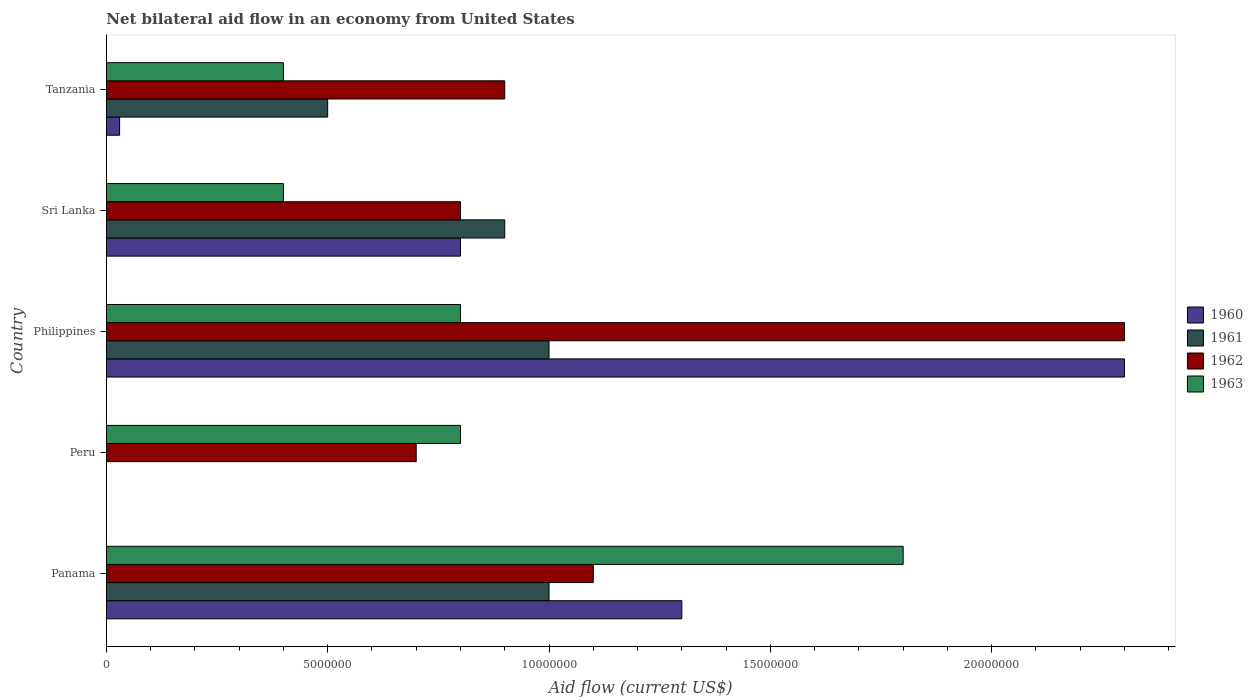How many groups of bars are there?
Your answer should be very brief. 5. Are the number of bars on each tick of the Y-axis equal?
Your response must be concise. No. How many bars are there on the 2nd tick from the bottom?
Your answer should be very brief. 2. What is the label of the 1st group of bars from the top?
Ensure brevity in your answer.  Tanzania. What is the net bilateral aid flow in 1962 in Panama?
Your answer should be compact. 1.10e+07. Across all countries, what is the maximum net bilateral aid flow in 1963?
Give a very brief answer. 1.80e+07. What is the total net bilateral aid flow in 1962 in the graph?
Keep it short and to the point. 5.80e+07. What is the difference between the net bilateral aid flow in 1962 in Peru and that in Tanzania?
Keep it short and to the point. -2.00e+06. What is the difference between the net bilateral aid flow in 1961 in Sri Lanka and the net bilateral aid flow in 1962 in Philippines?
Give a very brief answer. -1.40e+07. What is the average net bilateral aid flow in 1961 per country?
Offer a terse response. 6.80e+06. What is the difference between the net bilateral aid flow in 1963 and net bilateral aid flow in 1962 in Sri Lanka?
Keep it short and to the point. -4.00e+06. What is the ratio of the net bilateral aid flow in 1962 in Panama to that in Sri Lanka?
Give a very brief answer. 1.38. Is the net bilateral aid flow in 1960 in Panama less than that in Philippines?
Give a very brief answer. Yes. What is the difference between the highest and the second highest net bilateral aid flow in 1962?
Offer a very short reply. 1.20e+07. What is the difference between the highest and the lowest net bilateral aid flow in 1963?
Keep it short and to the point. 1.40e+07. Is the sum of the net bilateral aid flow in 1962 in Panama and Tanzania greater than the maximum net bilateral aid flow in 1961 across all countries?
Provide a short and direct response. Yes. Is it the case that in every country, the sum of the net bilateral aid flow in 1963 and net bilateral aid flow in 1961 is greater than the net bilateral aid flow in 1960?
Keep it short and to the point. No. Are all the bars in the graph horizontal?
Keep it short and to the point. Yes. Are the values on the major ticks of X-axis written in scientific E-notation?
Your answer should be very brief. No. How many legend labels are there?
Your answer should be very brief. 4. What is the title of the graph?
Offer a very short reply. Net bilateral aid flow in an economy from United States. Does "1967" appear as one of the legend labels in the graph?
Provide a succinct answer. No. What is the label or title of the X-axis?
Offer a very short reply. Aid flow (current US$). What is the label or title of the Y-axis?
Your response must be concise. Country. What is the Aid flow (current US$) of 1960 in Panama?
Provide a short and direct response. 1.30e+07. What is the Aid flow (current US$) in 1961 in Panama?
Offer a very short reply. 1.00e+07. What is the Aid flow (current US$) in 1962 in Panama?
Ensure brevity in your answer.  1.10e+07. What is the Aid flow (current US$) of 1963 in Panama?
Offer a very short reply. 1.80e+07. What is the Aid flow (current US$) of 1963 in Peru?
Provide a succinct answer. 8.00e+06. What is the Aid flow (current US$) of 1960 in Philippines?
Your answer should be compact. 2.30e+07. What is the Aid flow (current US$) of 1962 in Philippines?
Your answer should be compact. 2.30e+07. What is the Aid flow (current US$) of 1963 in Philippines?
Offer a very short reply. 8.00e+06. What is the Aid flow (current US$) in 1960 in Sri Lanka?
Provide a succinct answer. 8.00e+06. What is the Aid flow (current US$) in 1961 in Sri Lanka?
Your answer should be compact. 9.00e+06. What is the Aid flow (current US$) in 1962 in Sri Lanka?
Your answer should be compact. 8.00e+06. What is the Aid flow (current US$) of 1963 in Sri Lanka?
Keep it short and to the point. 4.00e+06. What is the Aid flow (current US$) in 1960 in Tanzania?
Give a very brief answer. 3.00e+05. What is the Aid flow (current US$) of 1961 in Tanzania?
Give a very brief answer. 5.00e+06. What is the Aid flow (current US$) of 1962 in Tanzania?
Keep it short and to the point. 9.00e+06. Across all countries, what is the maximum Aid flow (current US$) of 1960?
Provide a succinct answer. 2.30e+07. Across all countries, what is the maximum Aid flow (current US$) of 1962?
Your answer should be compact. 2.30e+07. Across all countries, what is the maximum Aid flow (current US$) in 1963?
Make the answer very short. 1.80e+07. Across all countries, what is the minimum Aid flow (current US$) of 1960?
Provide a succinct answer. 0. Across all countries, what is the minimum Aid flow (current US$) in 1961?
Make the answer very short. 0. Across all countries, what is the minimum Aid flow (current US$) of 1963?
Ensure brevity in your answer.  4.00e+06. What is the total Aid flow (current US$) in 1960 in the graph?
Offer a very short reply. 4.43e+07. What is the total Aid flow (current US$) in 1961 in the graph?
Provide a succinct answer. 3.40e+07. What is the total Aid flow (current US$) in 1962 in the graph?
Provide a succinct answer. 5.80e+07. What is the total Aid flow (current US$) in 1963 in the graph?
Make the answer very short. 4.20e+07. What is the difference between the Aid flow (current US$) in 1962 in Panama and that in Peru?
Offer a terse response. 4.00e+06. What is the difference between the Aid flow (current US$) in 1960 in Panama and that in Philippines?
Make the answer very short. -1.00e+07. What is the difference between the Aid flow (current US$) of 1962 in Panama and that in Philippines?
Your answer should be compact. -1.20e+07. What is the difference between the Aid flow (current US$) in 1960 in Panama and that in Sri Lanka?
Your answer should be very brief. 5.00e+06. What is the difference between the Aid flow (current US$) in 1961 in Panama and that in Sri Lanka?
Ensure brevity in your answer.  1.00e+06. What is the difference between the Aid flow (current US$) of 1963 in Panama and that in Sri Lanka?
Your answer should be very brief. 1.40e+07. What is the difference between the Aid flow (current US$) of 1960 in Panama and that in Tanzania?
Offer a very short reply. 1.27e+07. What is the difference between the Aid flow (current US$) in 1962 in Panama and that in Tanzania?
Your answer should be compact. 2.00e+06. What is the difference between the Aid flow (current US$) in 1963 in Panama and that in Tanzania?
Make the answer very short. 1.40e+07. What is the difference between the Aid flow (current US$) of 1962 in Peru and that in Philippines?
Offer a very short reply. -1.60e+07. What is the difference between the Aid flow (current US$) of 1962 in Peru and that in Sri Lanka?
Provide a short and direct response. -1.00e+06. What is the difference between the Aid flow (current US$) in 1962 in Peru and that in Tanzania?
Make the answer very short. -2.00e+06. What is the difference between the Aid flow (current US$) in 1960 in Philippines and that in Sri Lanka?
Provide a short and direct response. 1.50e+07. What is the difference between the Aid flow (current US$) of 1961 in Philippines and that in Sri Lanka?
Keep it short and to the point. 1.00e+06. What is the difference between the Aid flow (current US$) of 1962 in Philippines and that in Sri Lanka?
Give a very brief answer. 1.50e+07. What is the difference between the Aid flow (current US$) of 1963 in Philippines and that in Sri Lanka?
Your answer should be very brief. 4.00e+06. What is the difference between the Aid flow (current US$) of 1960 in Philippines and that in Tanzania?
Make the answer very short. 2.27e+07. What is the difference between the Aid flow (current US$) in 1961 in Philippines and that in Tanzania?
Keep it short and to the point. 5.00e+06. What is the difference between the Aid flow (current US$) of 1962 in Philippines and that in Tanzania?
Provide a succinct answer. 1.40e+07. What is the difference between the Aid flow (current US$) in 1963 in Philippines and that in Tanzania?
Your response must be concise. 4.00e+06. What is the difference between the Aid flow (current US$) in 1960 in Sri Lanka and that in Tanzania?
Your answer should be compact. 7.70e+06. What is the difference between the Aid flow (current US$) in 1961 in Sri Lanka and that in Tanzania?
Your answer should be very brief. 4.00e+06. What is the difference between the Aid flow (current US$) in 1962 in Sri Lanka and that in Tanzania?
Offer a very short reply. -1.00e+06. What is the difference between the Aid flow (current US$) of 1963 in Sri Lanka and that in Tanzania?
Your answer should be compact. 0. What is the difference between the Aid flow (current US$) of 1961 in Panama and the Aid flow (current US$) of 1962 in Peru?
Your response must be concise. 3.00e+06. What is the difference between the Aid flow (current US$) of 1961 in Panama and the Aid flow (current US$) of 1963 in Peru?
Offer a very short reply. 2.00e+06. What is the difference between the Aid flow (current US$) in 1962 in Panama and the Aid flow (current US$) in 1963 in Peru?
Make the answer very short. 3.00e+06. What is the difference between the Aid flow (current US$) of 1960 in Panama and the Aid flow (current US$) of 1962 in Philippines?
Provide a short and direct response. -1.00e+07. What is the difference between the Aid flow (current US$) of 1961 in Panama and the Aid flow (current US$) of 1962 in Philippines?
Your response must be concise. -1.30e+07. What is the difference between the Aid flow (current US$) of 1961 in Panama and the Aid flow (current US$) of 1963 in Philippines?
Make the answer very short. 2.00e+06. What is the difference between the Aid flow (current US$) in 1962 in Panama and the Aid flow (current US$) in 1963 in Philippines?
Offer a very short reply. 3.00e+06. What is the difference between the Aid flow (current US$) in 1960 in Panama and the Aid flow (current US$) in 1961 in Sri Lanka?
Offer a very short reply. 4.00e+06. What is the difference between the Aid flow (current US$) in 1960 in Panama and the Aid flow (current US$) in 1963 in Sri Lanka?
Your response must be concise. 9.00e+06. What is the difference between the Aid flow (current US$) of 1961 in Panama and the Aid flow (current US$) of 1963 in Sri Lanka?
Your answer should be very brief. 6.00e+06. What is the difference between the Aid flow (current US$) in 1962 in Panama and the Aid flow (current US$) in 1963 in Sri Lanka?
Offer a terse response. 7.00e+06. What is the difference between the Aid flow (current US$) in 1960 in Panama and the Aid flow (current US$) in 1961 in Tanzania?
Provide a short and direct response. 8.00e+06. What is the difference between the Aid flow (current US$) of 1960 in Panama and the Aid flow (current US$) of 1963 in Tanzania?
Offer a very short reply. 9.00e+06. What is the difference between the Aid flow (current US$) of 1961 in Panama and the Aid flow (current US$) of 1962 in Tanzania?
Offer a very short reply. 1.00e+06. What is the difference between the Aid flow (current US$) of 1961 in Panama and the Aid flow (current US$) of 1963 in Tanzania?
Make the answer very short. 6.00e+06. What is the difference between the Aid flow (current US$) in 1962 in Panama and the Aid flow (current US$) in 1963 in Tanzania?
Your response must be concise. 7.00e+06. What is the difference between the Aid flow (current US$) of 1962 in Peru and the Aid flow (current US$) of 1963 in Philippines?
Give a very brief answer. -1.00e+06. What is the difference between the Aid flow (current US$) of 1962 in Peru and the Aid flow (current US$) of 1963 in Sri Lanka?
Give a very brief answer. 3.00e+06. What is the difference between the Aid flow (current US$) of 1960 in Philippines and the Aid flow (current US$) of 1961 in Sri Lanka?
Make the answer very short. 1.40e+07. What is the difference between the Aid flow (current US$) in 1960 in Philippines and the Aid flow (current US$) in 1962 in Sri Lanka?
Offer a terse response. 1.50e+07. What is the difference between the Aid flow (current US$) in 1960 in Philippines and the Aid flow (current US$) in 1963 in Sri Lanka?
Keep it short and to the point. 1.90e+07. What is the difference between the Aid flow (current US$) in 1961 in Philippines and the Aid flow (current US$) in 1962 in Sri Lanka?
Your answer should be very brief. 2.00e+06. What is the difference between the Aid flow (current US$) in 1962 in Philippines and the Aid flow (current US$) in 1963 in Sri Lanka?
Provide a succinct answer. 1.90e+07. What is the difference between the Aid flow (current US$) of 1960 in Philippines and the Aid flow (current US$) of 1961 in Tanzania?
Your answer should be compact. 1.80e+07. What is the difference between the Aid flow (current US$) in 1960 in Philippines and the Aid flow (current US$) in 1962 in Tanzania?
Offer a terse response. 1.40e+07. What is the difference between the Aid flow (current US$) in 1960 in Philippines and the Aid flow (current US$) in 1963 in Tanzania?
Your response must be concise. 1.90e+07. What is the difference between the Aid flow (current US$) in 1961 in Philippines and the Aid flow (current US$) in 1962 in Tanzania?
Provide a succinct answer. 1.00e+06. What is the difference between the Aid flow (current US$) of 1961 in Philippines and the Aid flow (current US$) of 1963 in Tanzania?
Offer a terse response. 6.00e+06. What is the difference between the Aid flow (current US$) of 1962 in Philippines and the Aid flow (current US$) of 1963 in Tanzania?
Keep it short and to the point. 1.90e+07. What is the difference between the Aid flow (current US$) of 1960 in Sri Lanka and the Aid flow (current US$) of 1961 in Tanzania?
Your response must be concise. 3.00e+06. What is the average Aid flow (current US$) of 1960 per country?
Provide a short and direct response. 8.86e+06. What is the average Aid flow (current US$) of 1961 per country?
Give a very brief answer. 6.80e+06. What is the average Aid flow (current US$) in 1962 per country?
Your answer should be compact. 1.16e+07. What is the average Aid flow (current US$) in 1963 per country?
Ensure brevity in your answer.  8.40e+06. What is the difference between the Aid flow (current US$) in 1960 and Aid flow (current US$) in 1963 in Panama?
Keep it short and to the point. -5.00e+06. What is the difference between the Aid flow (current US$) of 1961 and Aid flow (current US$) of 1962 in Panama?
Give a very brief answer. -1.00e+06. What is the difference between the Aid flow (current US$) in 1961 and Aid flow (current US$) in 1963 in Panama?
Offer a very short reply. -8.00e+06. What is the difference between the Aid flow (current US$) of 1962 and Aid flow (current US$) of 1963 in Panama?
Your answer should be very brief. -7.00e+06. What is the difference between the Aid flow (current US$) in 1962 and Aid flow (current US$) in 1963 in Peru?
Your answer should be very brief. -1.00e+06. What is the difference between the Aid flow (current US$) in 1960 and Aid flow (current US$) in 1961 in Philippines?
Make the answer very short. 1.30e+07. What is the difference between the Aid flow (current US$) of 1960 and Aid flow (current US$) of 1963 in Philippines?
Your answer should be compact. 1.50e+07. What is the difference between the Aid flow (current US$) of 1961 and Aid flow (current US$) of 1962 in Philippines?
Your answer should be compact. -1.30e+07. What is the difference between the Aid flow (current US$) of 1961 and Aid flow (current US$) of 1963 in Philippines?
Offer a terse response. 2.00e+06. What is the difference between the Aid flow (current US$) in 1962 and Aid flow (current US$) in 1963 in Philippines?
Your response must be concise. 1.50e+07. What is the difference between the Aid flow (current US$) of 1960 and Aid flow (current US$) of 1961 in Sri Lanka?
Your answer should be compact. -1.00e+06. What is the difference between the Aid flow (current US$) of 1960 and Aid flow (current US$) of 1962 in Sri Lanka?
Your response must be concise. 0. What is the difference between the Aid flow (current US$) of 1960 and Aid flow (current US$) of 1963 in Sri Lanka?
Keep it short and to the point. 4.00e+06. What is the difference between the Aid flow (current US$) of 1961 and Aid flow (current US$) of 1963 in Sri Lanka?
Give a very brief answer. 5.00e+06. What is the difference between the Aid flow (current US$) of 1962 and Aid flow (current US$) of 1963 in Sri Lanka?
Provide a short and direct response. 4.00e+06. What is the difference between the Aid flow (current US$) in 1960 and Aid flow (current US$) in 1961 in Tanzania?
Keep it short and to the point. -4.70e+06. What is the difference between the Aid flow (current US$) in 1960 and Aid flow (current US$) in 1962 in Tanzania?
Your answer should be compact. -8.70e+06. What is the difference between the Aid flow (current US$) of 1960 and Aid flow (current US$) of 1963 in Tanzania?
Offer a very short reply. -3.70e+06. What is the difference between the Aid flow (current US$) of 1961 and Aid flow (current US$) of 1962 in Tanzania?
Keep it short and to the point. -4.00e+06. What is the difference between the Aid flow (current US$) in 1961 and Aid flow (current US$) in 1963 in Tanzania?
Offer a terse response. 1.00e+06. What is the ratio of the Aid flow (current US$) in 1962 in Panama to that in Peru?
Your answer should be very brief. 1.57. What is the ratio of the Aid flow (current US$) of 1963 in Panama to that in Peru?
Give a very brief answer. 2.25. What is the ratio of the Aid flow (current US$) in 1960 in Panama to that in Philippines?
Provide a short and direct response. 0.57. What is the ratio of the Aid flow (current US$) of 1961 in Panama to that in Philippines?
Provide a short and direct response. 1. What is the ratio of the Aid flow (current US$) of 1962 in Panama to that in Philippines?
Provide a short and direct response. 0.48. What is the ratio of the Aid flow (current US$) in 1963 in Panama to that in Philippines?
Provide a short and direct response. 2.25. What is the ratio of the Aid flow (current US$) of 1960 in Panama to that in Sri Lanka?
Your answer should be compact. 1.62. What is the ratio of the Aid flow (current US$) in 1961 in Panama to that in Sri Lanka?
Offer a terse response. 1.11. What is the ratio of the Aid flow (current US$) of 1962 in Panama to that in Sri Lanka?
Your response must be concise. 1.38. What is the ratio of the Aid flow (current US$) of 1963 in Panama to that in Sri Lanka?
Provide a short and direct response. 4.5. What is the ratio of the Aid flow (current US$) of 1960 in Panama to that in Tanzania?
Keep it short and to the point. 43.33. What is the ratio of the Aid flow (current US$) of 1961 in Panama to that in Tanzania?
Give a very brief answer. 2. What is the ratio of the Aid flow (current US$) of 1962 in Panama to that in Tanzania?
Give a very brief answer. 1.22. What is the ratio of the Aid flow (current US$) of 1963 in Panama to that in Tanzania?
Your answer should be very brief. 4.5. What is the ratio of the Aid flow (current US$) in 1962 in Peru to that in Philippines?
Your answer should be compact. 0.3. What is the ratio of the Aid flow (current US$) of 1963 in Peru to that in Sri Lanka?
Your answer should be very brief. 2. What is the ratio of the Aid flow (current US$) of 1963 in Peru to that in Tanzania?
Provide a succinct answer. 2. What is the ratio of the Aid flow (current US$) in 1960 in Philippines to that in Sri Lanka?
Your answer should be compact. 2.88. What is the ratio of the Aid flow (current US$) of 1962 in Philippines to that in Sri Lanka?
Your answer should be compact. 2.88. What is the ratio of the Aid flow (current US$) of 1963 in Philippines to that in Sri Lanka?
Your answer should be very brief. 2. What is the ratio of the Aid flow (current US$) of 1960 in Philippines to that in Tanzania?
Your response must be concise. 76.67. What is the ratio of the Aid flow (current US$) in 1962 in Philippines to that in Tanzania?
Keep it short and to the point. 2.56. What is the ratio of the Aid flow (current US$) of 1960 in Sri Lanka to that in Tanzania?
Your response must be concise. 26.67. What is the difference between the highest and the second highest Aid flow (current US$) in 1962?
Keep it short and to the point. 1.20e+07. What is the difference between the highest and the lowest Aid flow (current US$) of 1960?
Offer a very short reply. 2.30e+07. What is the difference between the highest and the lowest Aid flow (current US$) in 1961?
Your answer should be compact. 1.00e+07. What is the difference between the highest and the lowest Aid flow (current US$) of 1962?
Give a very brief answer. 1.60e+07. What is the difference between the highest and the lowest Aid flow (current US$) of 1963?
Your response must be concise. 1.40e+07. 